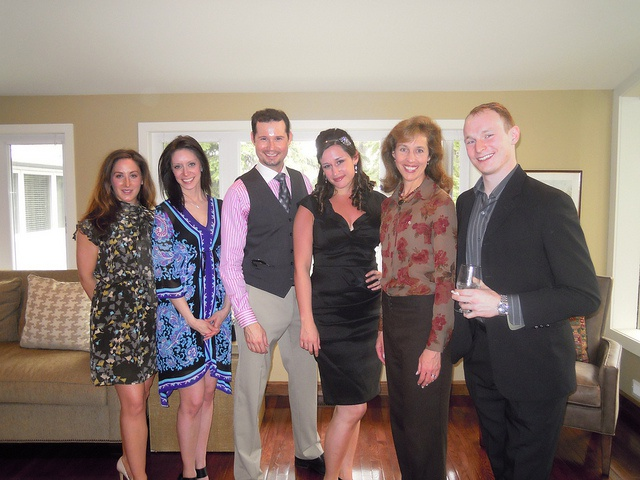Describe the objects in this image and their specific colors. I can see people in darkgray, black, gray, lightpink, and lightgray tones, people in darkgray, black, gray, and lightpink tones, people in darkgray, black, brown, gray, and maroon tones, people in darkgray, gray, violet, and lightpink tones, and people in darkgray, black, salmon, and gray tones in this image. 